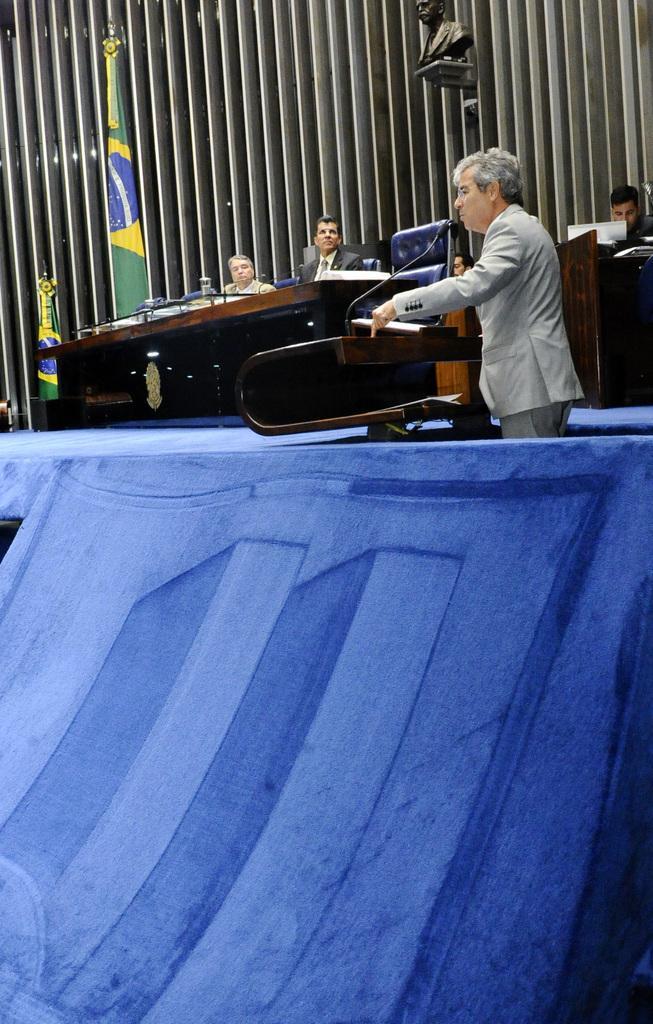In one or two sentences, can you explain what this image depicts? In this image I can see people where one is standing and few are sitting on chairs. I can also see tables, a green colour flag, a podium and a mic on it. I can see they all are wearing formal dress. 